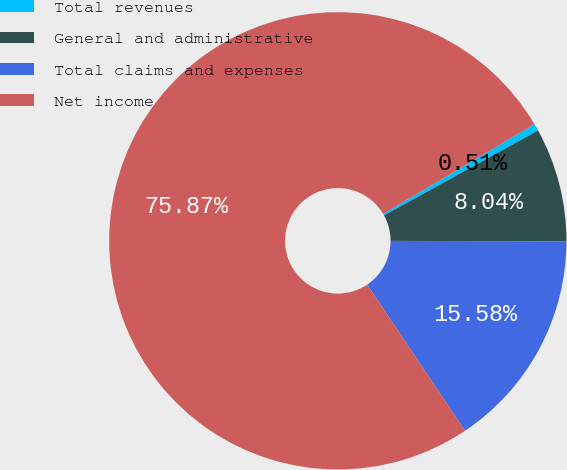<chart> <loc_0><loc_0><loc_500><loc_500><pie_chart><fcel>Total revenues<fcel>General and administrative<fcel>Total claims and expenses<fcel>Net income<nl><fcel>0.51%<fcel>8.04%<fcel>15.58%<fcel>75.87%<nl></chart> 